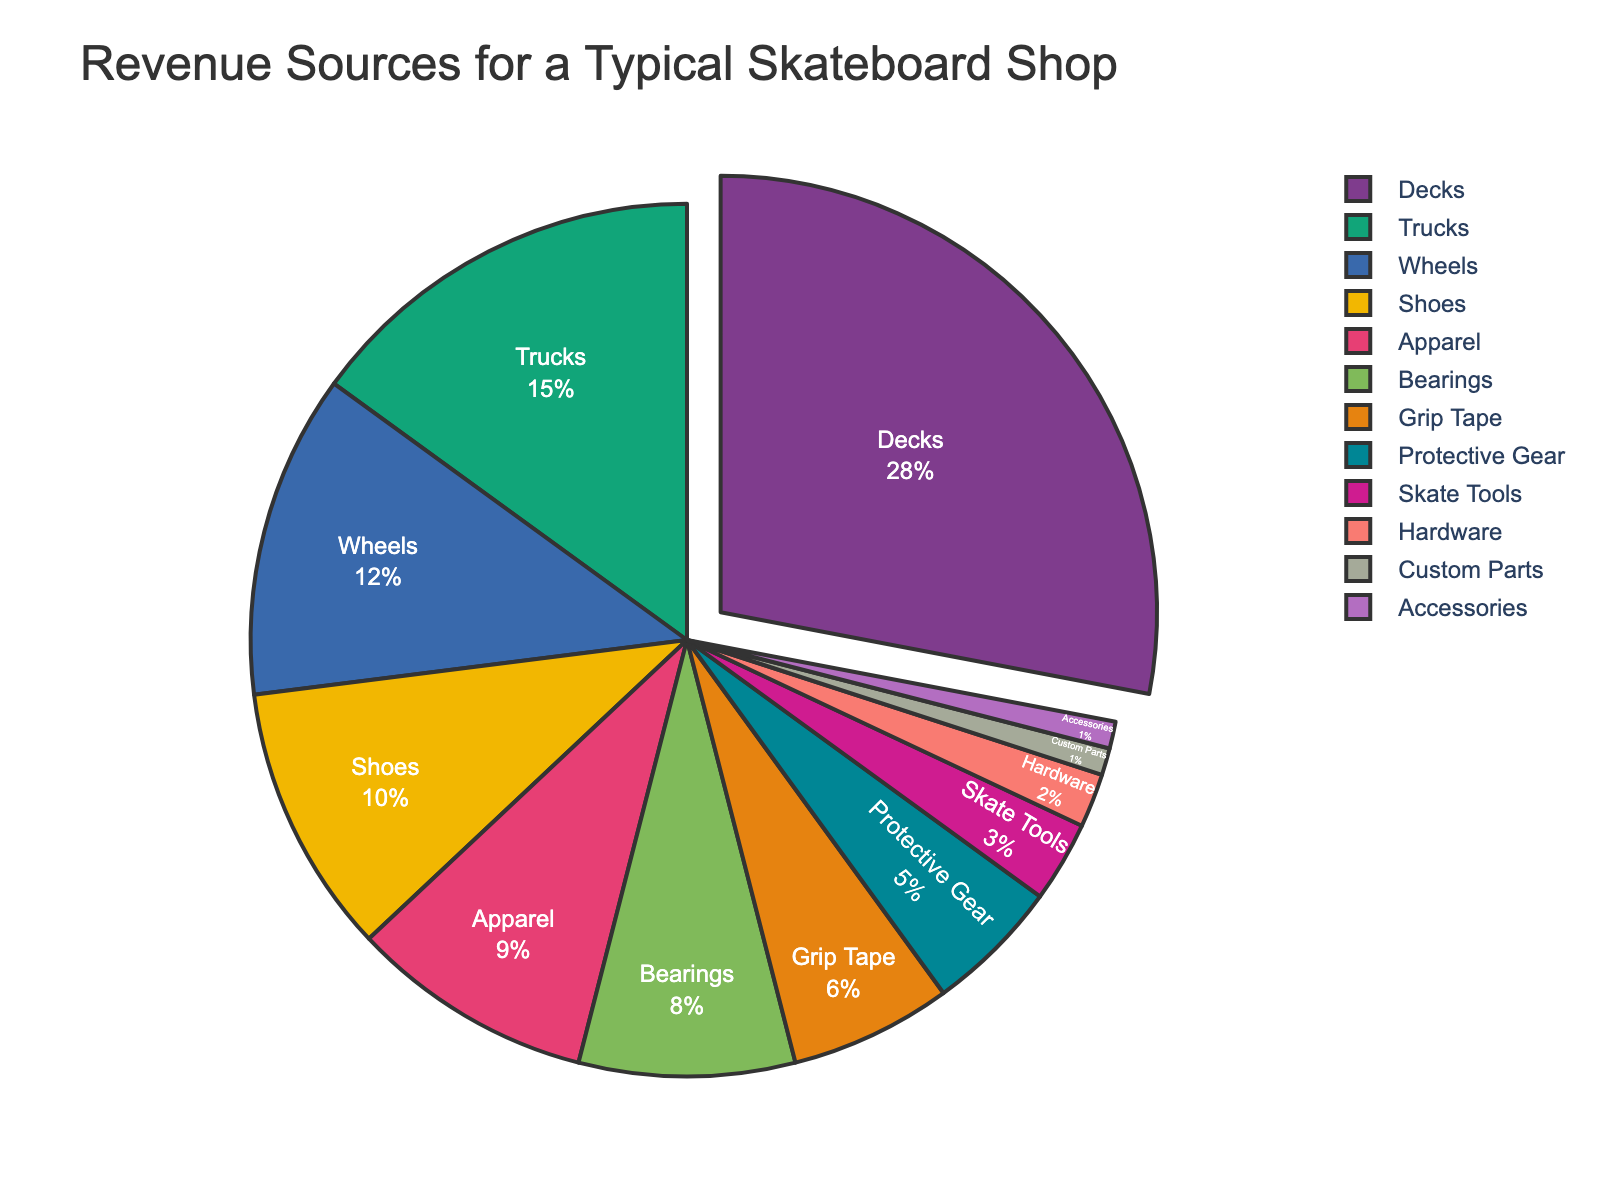What percentage of revenue comes from decks? The pie chart shows that decks contribute 28% to the total revenue.
Answer: 28% Which category contributes the least to the revenue? The pie chart indicates that custom parts and accessories each contribute 1%, which are the lowest percentages.
Answer: Custom Parts, Accessories How does the percentage of revenue from wheels compare to the percentage from bearings? The pie chart shows wheels contribute 12% while bearings contribute 8%. 12% is greater than 8%.
Answer: Wheels: 12%, Bearings: 8% What is the combined percentage of revenue from protective gear and skate tools? The pie chart indicates protective gear contributes 5% and skate tools contribute 3%. Adding these, 5% + 3% = 8%.
Answer: 8% Which category contributes more to the revenue: apparel or shoes? According to the pie chart, apparel contributes 9% and shoes contribute 10%. Shoes contribute more.
Answer: Shoes: 10% What is the difference in revenue percentage between grip tape and hardware? Grip tape and hardware contribute 6% and 2% respectively. The difference is 6% - 2% = 4%.
Answer: 4% Is the revenue from decks more than double the revenue from trucks? Decks contribute 28% and trucks contribute 15%. 28% is not more than twice 15% (which is 30%).
Answer: No What is the total percentage of revenue contributed by decks, trucks, and wheels combined? Adding the percentages from the pie chart: Decks (28%) + Trucks (15%) + Wheels (12%). The total is 28% + 15% + 12% = 55%.
Answer: 55% Which categories each contribute exactly 1% to the revenue? The pie chart shows that custom parts and accessories each contribute 1% to the revenue.
Answer: Custom Parts, Accessories What is the average revenue percentage of the top three categories? The top three categories by percentage are decks (28%), trucks (15%), and wheels (12%). The average is (28% + 15% + 12%) / 3 = 55% / 3 ≈ 18.33%.
Answer: 18.33% 